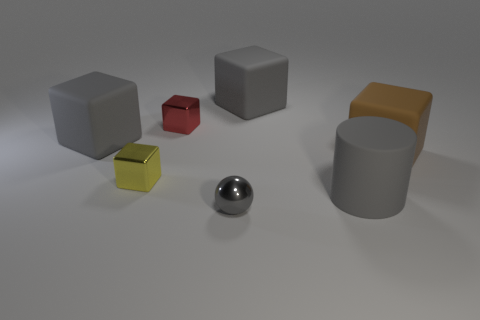Subtract all yellow cubes. How many cubes are left? 4 Subtract all brown cubes. How many cubes are left? 4 Subtract all purple blocks. Subtract all yellow spheres. How many blocks are left? 5 Add 1 large gray rubber cubes. How many objects exist? 8 Subtract all balls. How many objects are left? 6 Subtract all large cylinders. Subtract all tiny red metal blocks. How many objects are left? 5 Add 7 big brown cubes. How many big brown cubes are left? 8 Add 2 large cyan metal things. How many large cyan metal things exist? 2 Subtract 0 purple spheres. How many objects are left? 7 